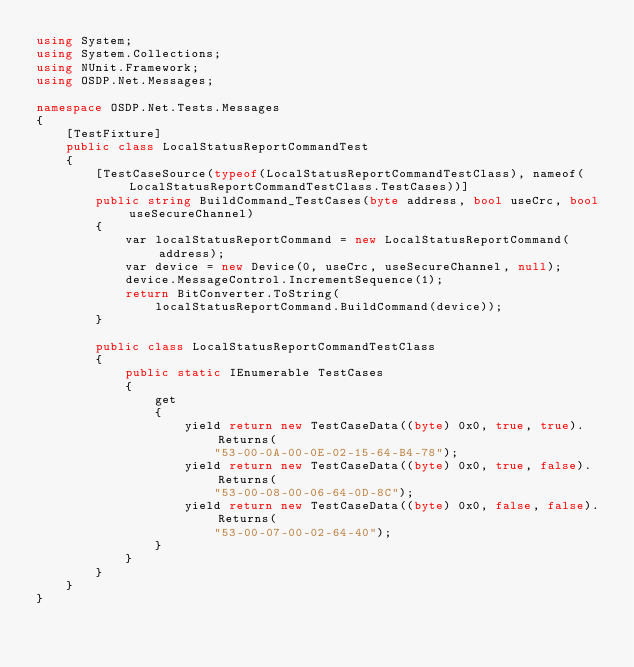Convert code to text. <code><loc_0><loc_0><loc_500><loc_500><_C#_>using System;
using System.Collections;
using NUnit.Framework;
using OSDP.Net.Messages;

namespace OSDP.Net.Tests.Messages
{
    [TestFixture]
    public class LocalStatusReportCommandTest
    {
        [TestCaseSource(typeof(LocalStatusReportCommandTestClass), nameof(LocalStatusReportCommandTestClass.TestCases))]
        public string BuildCommand_TestCases(byte address, bool useCrc, bool useSecureChannel)
        {
            var localStatusReportCommand = new LocalStatusReportCommand(address);
            var device = new Device(0, useCrc, useSecureChannel, null);
            device.MessageControl.IncrementSequence(1);
            return BitConverter.ToString(
                localStatusReportCommand.BuildCommand(device));
        }

        public class LocalStatusReportCommandTestClass
        {
            public static IEnumerable TestCases
            {
                get
                {
                    yield return new TestCaseData((byte) 0x0, true, true).Returns(
                        "53-00-0A-00-0E-02-15-64-B4-78");
                    yield return new TestCaseData((byte) 0x0, true, false).Returns(
                        "53-00-08-00-06-64-0D-8C");
                    yield return new TestCaseData((byte) 0x0, false, false).Returns(
                        "53-00-07-00-02-64-40");
                }
            }
        }
    }
}</code> 